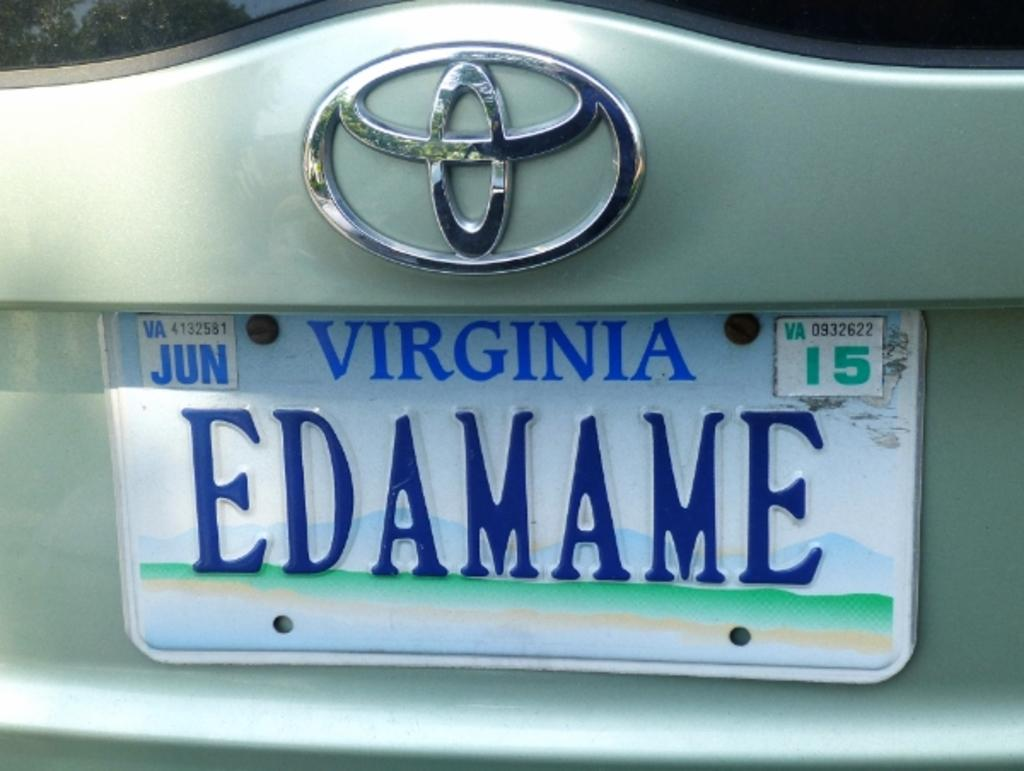<image>
Offer a succinct explanation of the picture presented. A green Audi vehicle with a license plate of EDAMAME. 